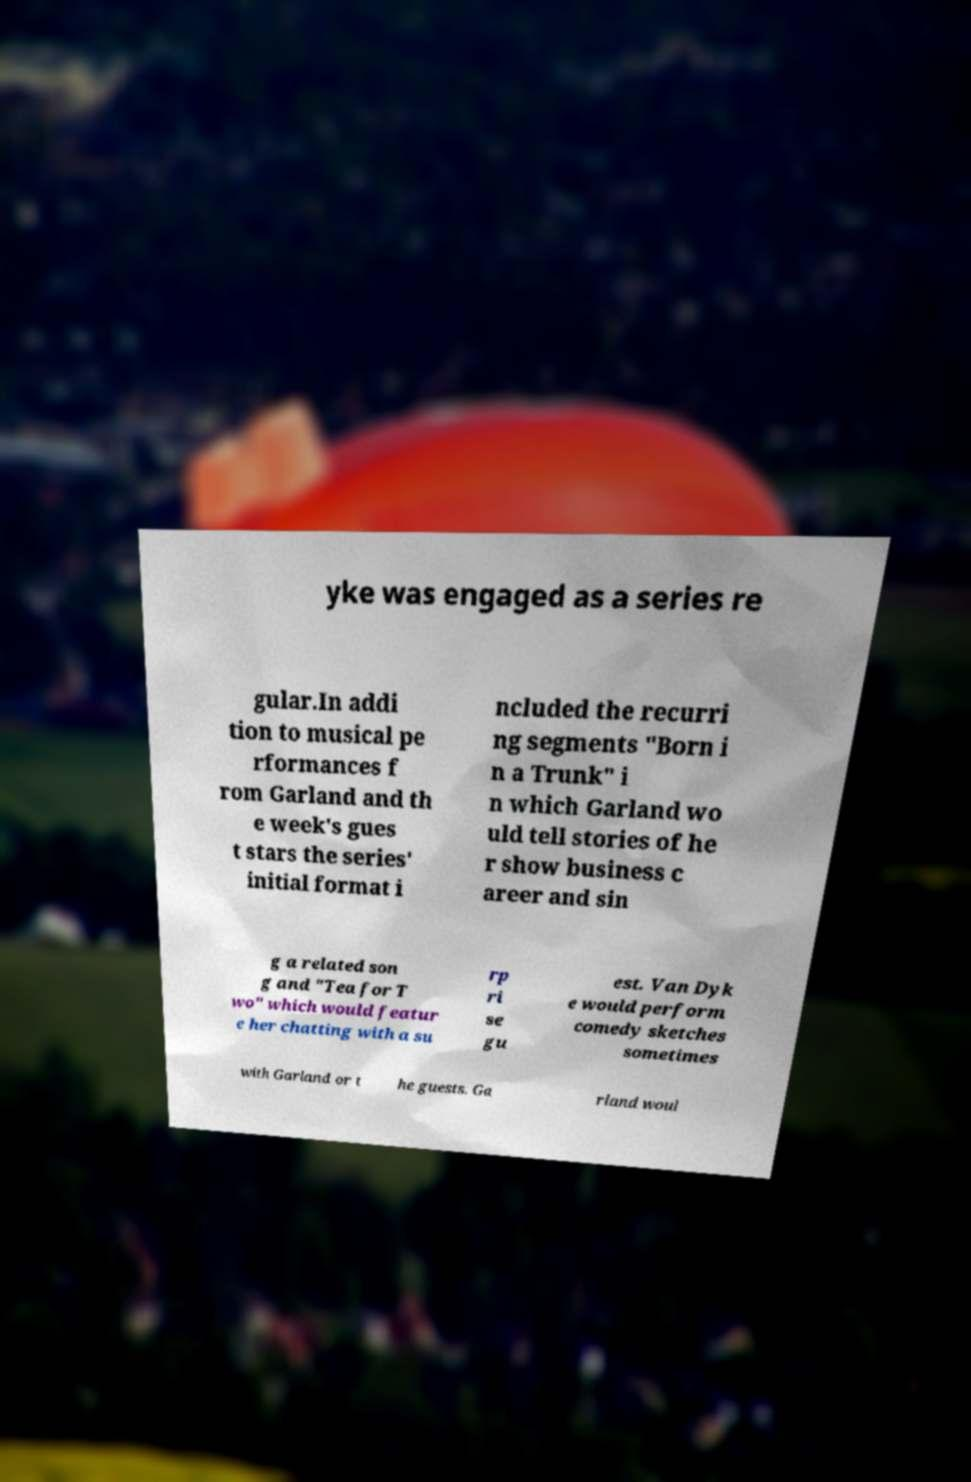I need the written content from this picture converted into text. Can you do that? yke was engaged as a series re gular.In addi tion to musical pe rformances f rom Garland and th e week's gues t stars the series' initial format i ncluded the recurri ng segments "Born i n a Trunk" i n which Garland wo uld tell stories of he r show business c areer and sin g a related son g and "Tea for T wo" which would featur e her chatting with a su rp ri se gu est. Van Dyk e would perform comedy sketches sometimes with Garland or t he guests. Ga rland woul 